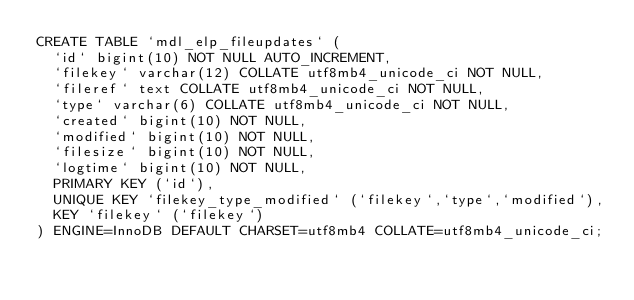Convert code to text. <code><loc_0><loc_0><loc_500><loc_500><_SQL_>CREATE TABLE `mdl_elp_fileupdates` (
  `id` bigint(10) NOT NULL AUTO_INCREMENT,
  `filekey` varchar(12) COLLATE utf8mb4_unicode_ci NOT NULL,
  `fileref` text COLLATE utf8mb4_unicode_ci NOT NULL,
  `type` varchar(6) COLLATE utf8mb4_unicode_ci NOT NULL,
  `created` bigint(10) NOT NULL,
  `modified` bigint(10) NOT NULL,
  `filesize` bigint(10) NOT NULL,
  `logtime` bigint(10) NOT NULL,
  PRIMARY KEY (`id`),
  UNIQUE KEY `filekey_type_modified` (`filekey`,`type`,`modified`),
  KEY `filekey` (`filekey`)
) ENGINE=InnoDB DEFAULT CHARSET=utf8mb4 COLLATE=utf8mb4_unicode_ci;
</code> 